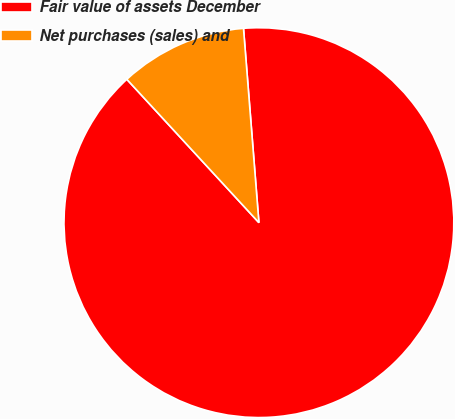<chart> <loc_0><loc_0><loc_500><loc_500><pie_chart><fcel>Fair value of assets December<fcel>Net purchases (sales) and<nl><fcel>89.41%<fcel>10.59%<nl></chart> 